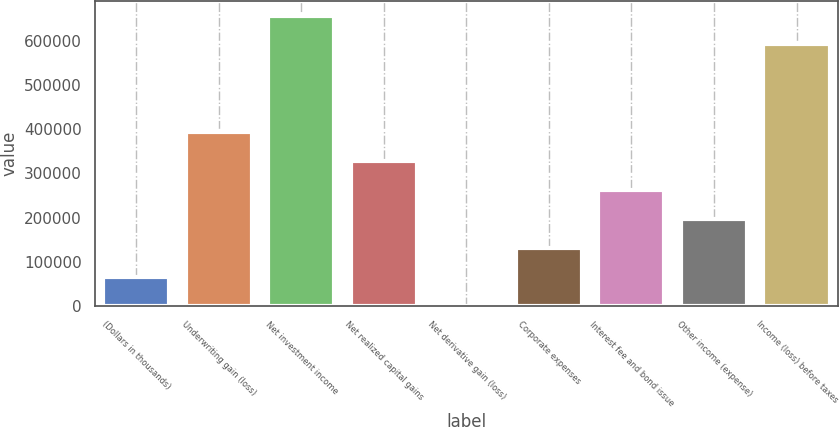Convert chart. <chart><loc_0><loc_0><loc_500><loc_500><bar_chart><fcel>(Dollars in thousands)<fcel>Underwriting gain (loss)<fcel>Net investment income<fcel>Net realized capital gains<fcel>Net derivative gain (loss)<fcel>Corporate expenses<fcel>Interest fee and bond issue<fcel>Other income (expense)<fcel>Income (loss) before taxes<nl><fcel>66353.4<fcel>392525<fcel>656472<fcel>327291<fcel>1119<fcel>131588<fcel>262057<fcel>196822<fcel>591238<nl></chart> 